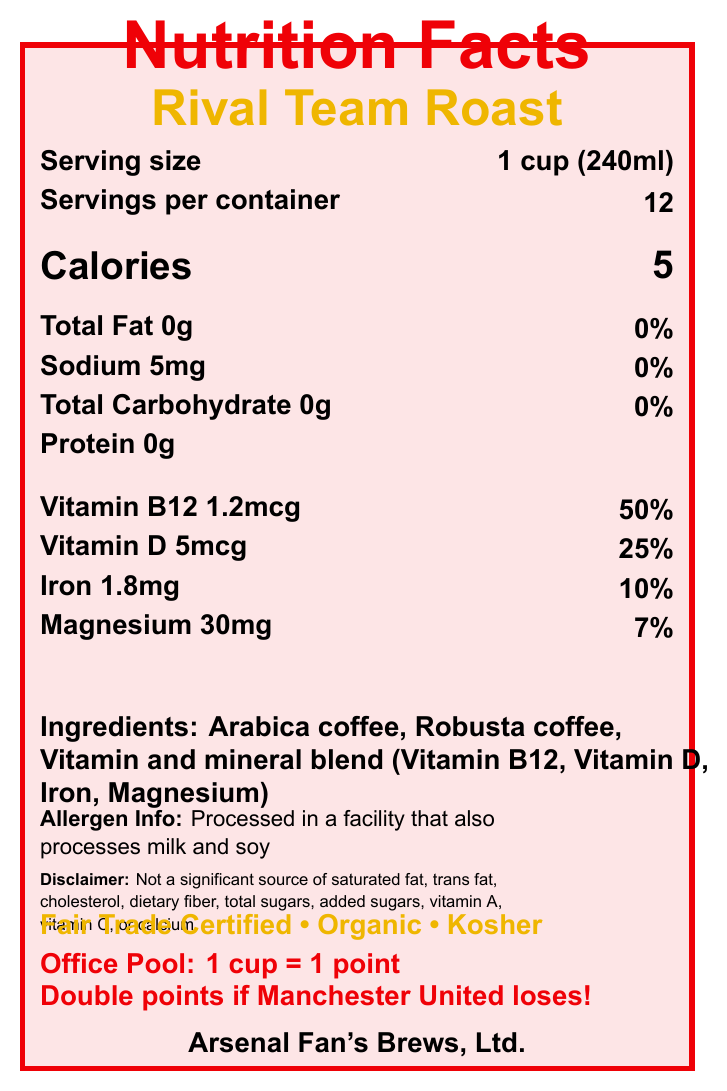what is the serving size? The serving size is stated in the section "Serving size" at the top of the document.
Answer: 1 cup (240ml) how many calories are in one serving of Rival Team Roast? The calories per serving are specified below the serving information in the document.
Answer: 5 name the vitamins and minerals included in the Rival Team Roast. The document lists these vitamins and minerals under the section labeled "Vitamins and Minerals".
Answer: Vitamin B12, Vitamin D, Iron, Magnesium what is the amount of sodium in one serving? The sodium content is provided in the macronutrients section of the document.
Answer: 5mg who is the manufacturer of the Rival Team Roast? The manufacturer information is displayed at the bottom of the document.
Answer: Arsenal Fan's Brews, Ltd. is the Rival Team Roast coffee blend Kosher certified? The special features section at the bottom of the document proves it is Kosher certified.
Answer: Yes what is the percentage daily value of Vitamin D in Rivals Team Roast per serving? The percentage daily value of Vitamin D is listed as 25% next to its amount.
Answer: 25% which vitamin has the highest percentage daily value in one serving? A. Vitamin B12 B. Vitamin D C. Iron D. Magnesium Vitamin B12 has the highest percentage daily value at 50%, according to the vitamins and minerals section.
Answer: A. Vitamin B12 how many servings are there per container? A. 10 B. 12 C. 14 D. 16 The servings per container are listed as 12 in the serving information section.
Answer: B. 12 does this coffee blend contain ingredients that can cause allergies? It is processed in a facility that also processes milk and soy, as stated in the allergen info.
Answer: Yes what perks are offered in the office pool related to Arsenal wins? This office pool fact is provided towards the bottom of the document.
Answer: Free refills on Mondays after an Arsenal victory who has won the most Premier League titles according to the trivia? The football trivia section answers this question.
Answer: Manchester United (13 titles) is saturated fat listed as a significant source in this product? The disclaimer mentions it is not a significant source of saturated fat.
Answer: No describe the main features and target audience of the Rival Team Roast coffee blend. The document details the nutritional content, ingredients, and special features, highlighting its suitability for healthy, ethical consumption while targeting football fans, especially those involved in office football pools.
Answer: Rival Team Roast is a coffee blend with added vitamins and minerals (Vitamin B12, Vitamin D, Iron, Magnesium). It is low in calories, fat, and sodium, and is marketed as being fair trade, organic, and kosher. It is produced by Arsenal Fan's Brews, Ltd., and includes elements tailored to office football pools. how long is the lifespan of the Rival Team Roast coffee blend once opened? The document does not provide any information regarding the lifespan of the coffee blend once the container is opened.
Answer: Cannot be determined 